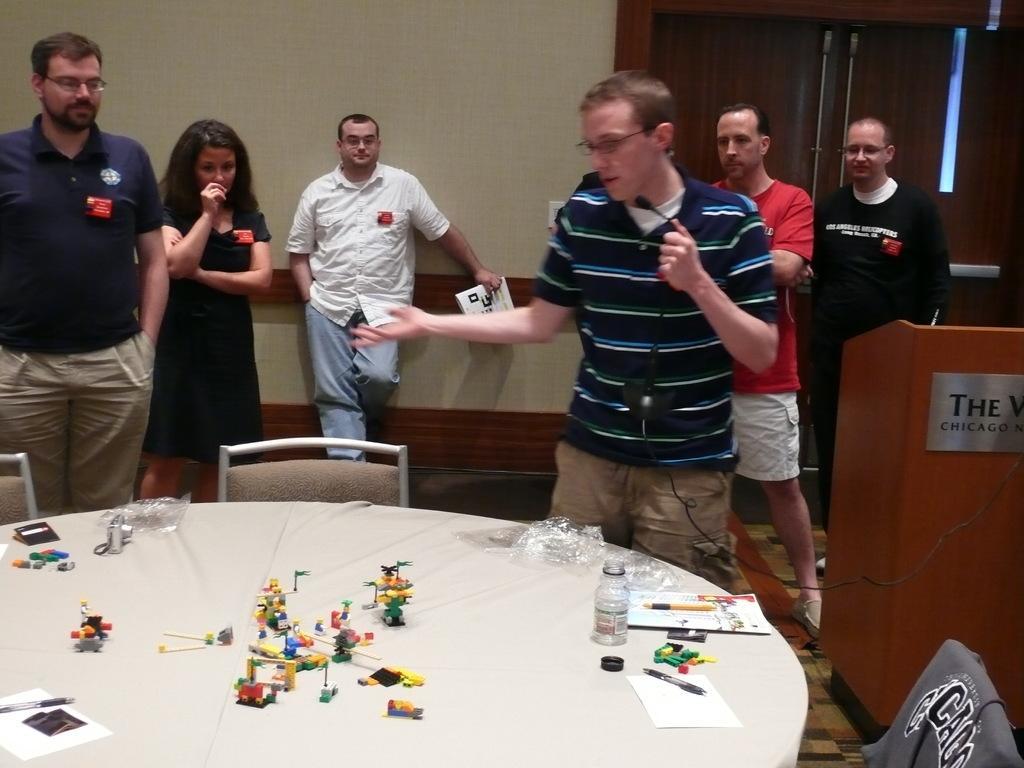Please provide a concise description of this image. Here we can see a group of people standing on the floor, and in front here is the table and toys and some objects on it, and here is the wall, and here is the door. 